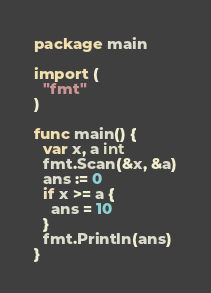<code> <loc_0><loc_0><loc_500><loc_500><_Go_>package main

import (
  "fmt"
)

func main() {
  var x, a int
  fmt.Scan(&x, &a)
  ans := 0
  if x >= a {
    ans = 10
  }
  fmt.Println(ans)
}</code> 